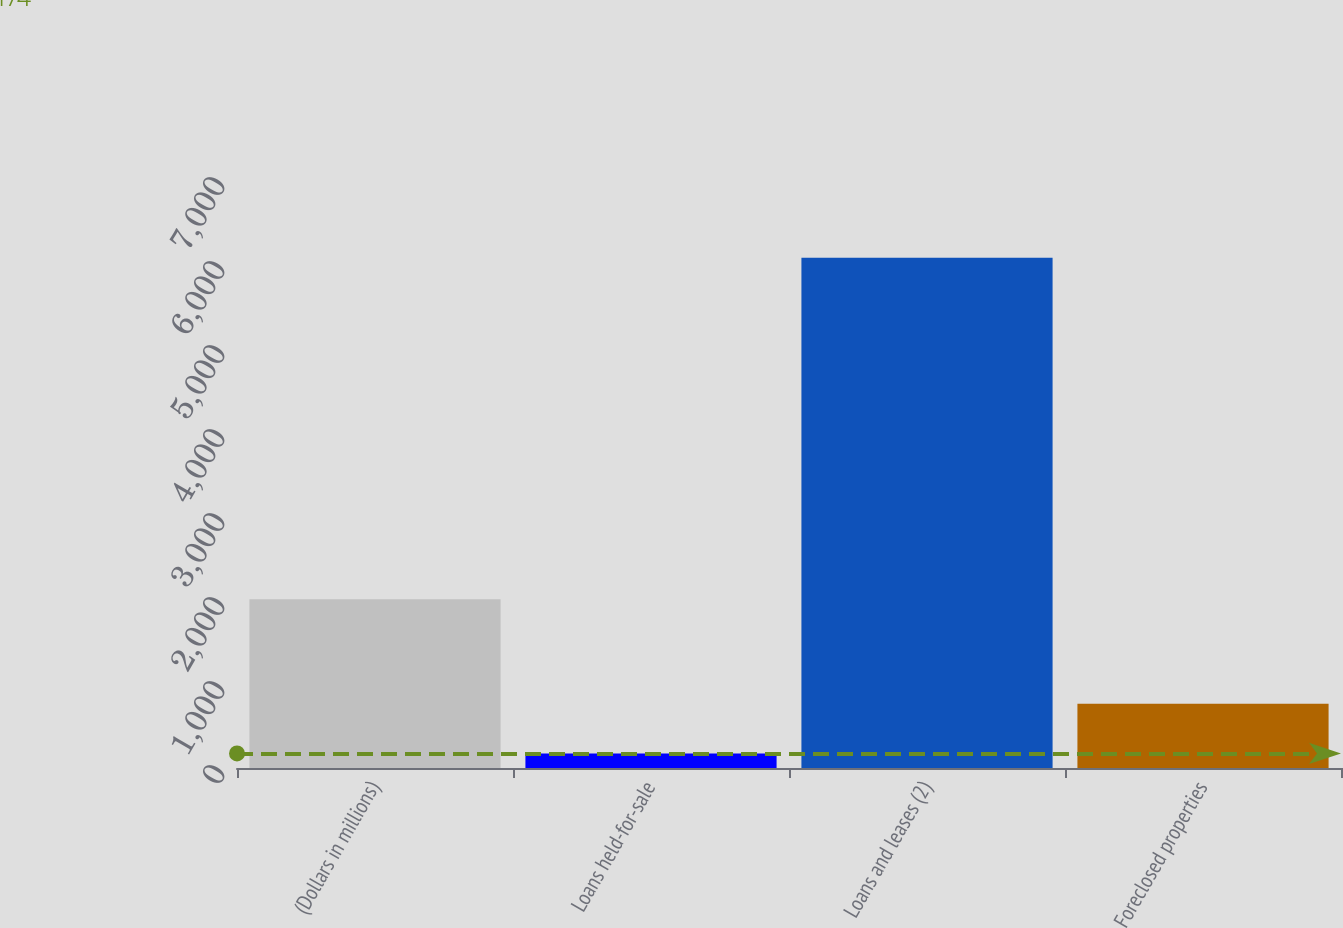Convert chart. <chart><loc_0><loc_0><loc_500><loc_500><bar_chart><fcel>(Dollars in millions)<fcel>Loans held-for-sale<fcel>Loans and leases (2)<fcel>Foreclosed properties<nl><fcel>2010<fcel>174<fcel>6074<fcel>764<nl></chart> 